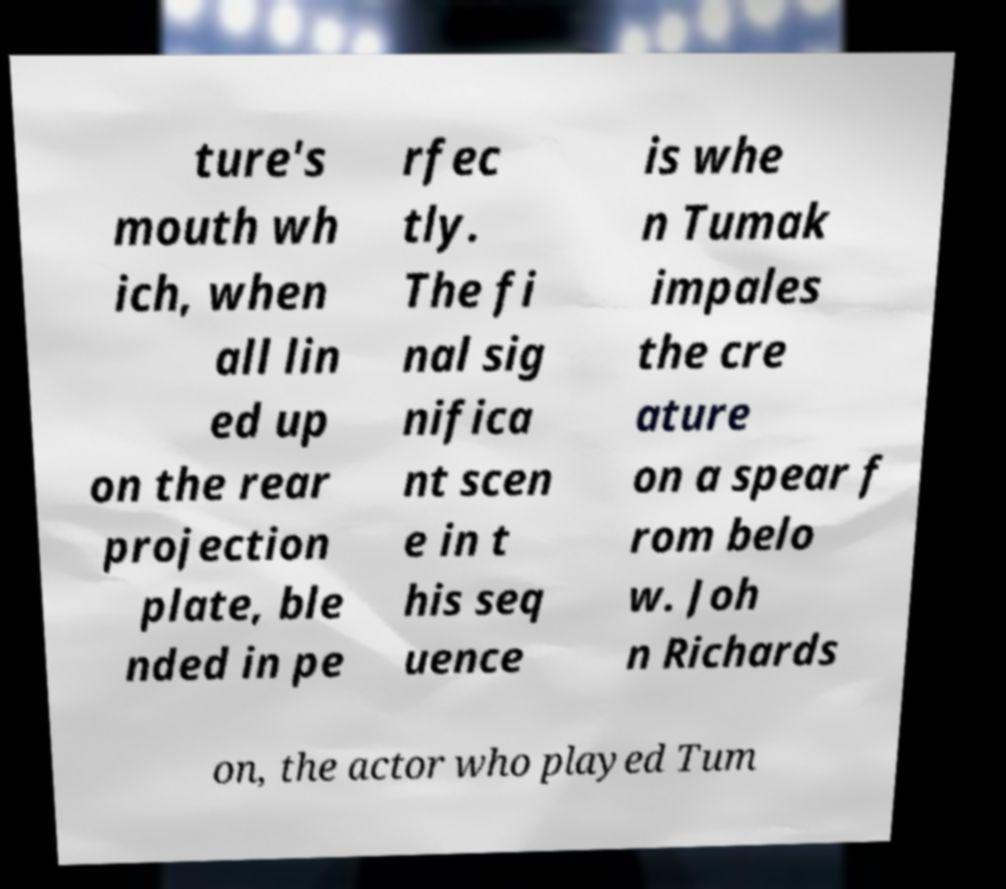Please read and relay the text visible in this image. What does it say? ture's mouth wh ich, when all lin ed up on the rear projection plate, ble nded in pe rfec tly. The fi nal sig nifica nt scen e in t his seq uence is whe n Tumak impales the cre ature on a spear f rom belo w. Joh n Richards on, the actor who played Tum 